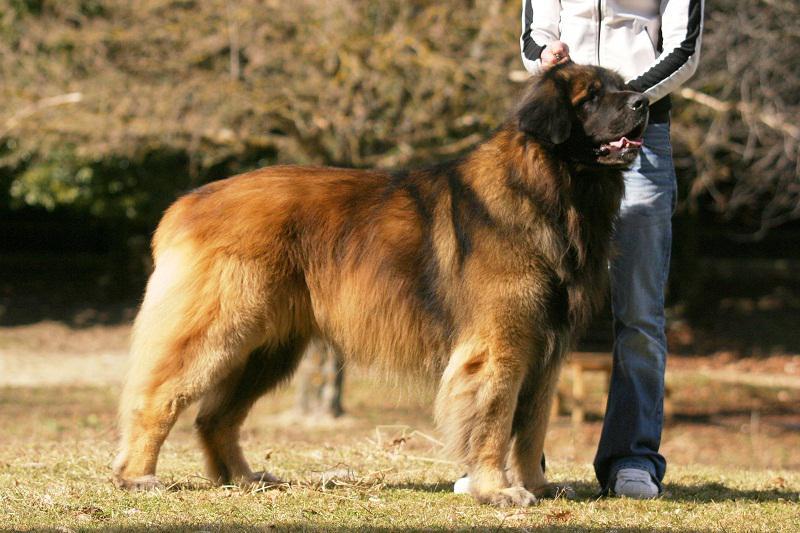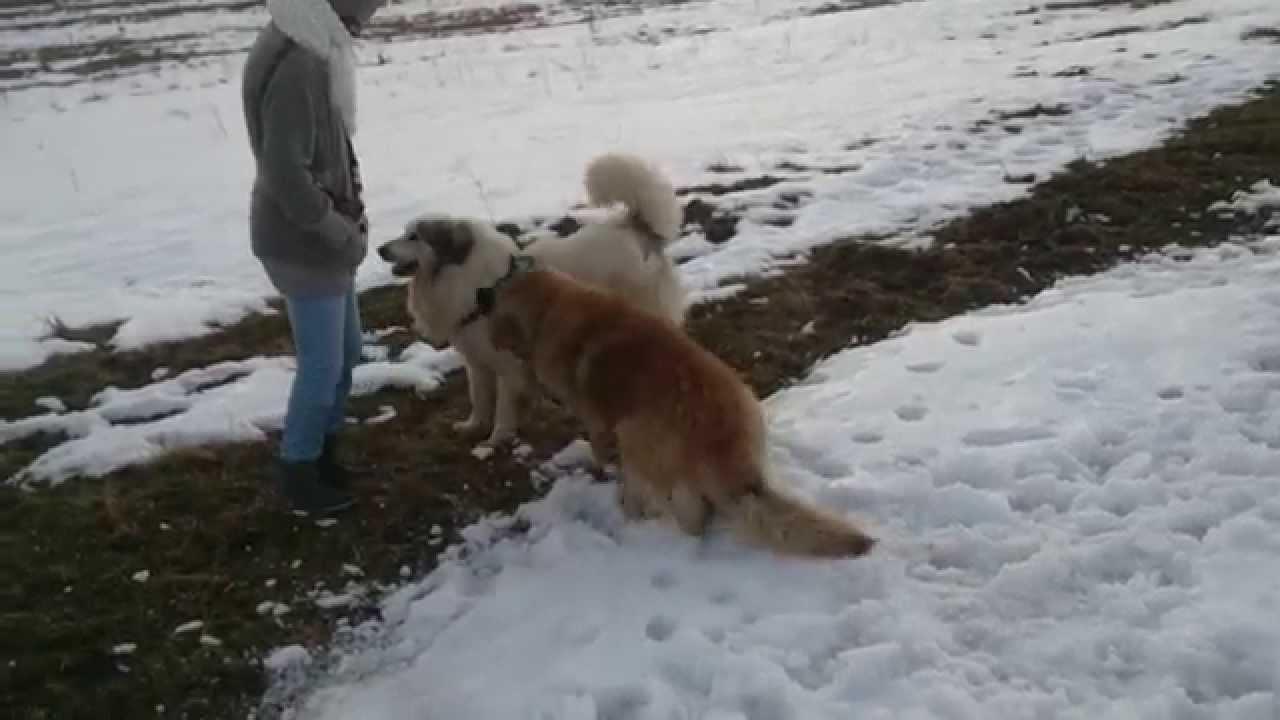The first image is the image on the left, the second image is the image on the right. Examine the images to the left and right. Is the description "In one of the images, one dog is predominantly white, while the other is predominantly brown." accurate? Answer yes or no. Yes. The first image is the image on the left, the second image is the image on the right. Assess this claim about the two images: "The right image has exactly two dogs.". Correct or not? Answer yes or no. Yes. 